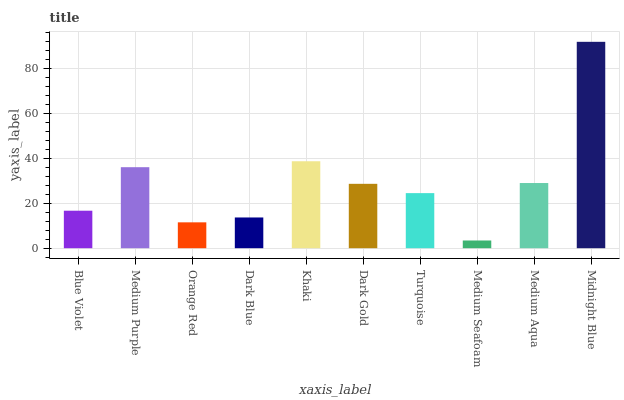Is Medium Seafoam the minimum?
Answer yes or no. Yes. Is Midnight Blue the maximum?
Answer yes or no. Yes. Is Medium Purple the minimum?
Answer yes or no. No. Is Medium Purple the maximum?
Answer yes or no. No. Is Medium Purple greater than Blue Violet?
Answer yes or no. Yes. Is Blue Violet less than Medium Purple?
Answer yes or no. Yes. Is Blue Violet greater than Medium Purple?
Answer yes or no. No. Is Medium Purple less than Blue Violet?
Answer yes or no. No. Is Dark Gold the high median?
Answer yes or no. Yes. Is Turquoise the low median?
Answer yes or no. Yes. Is Khaki the high median?
Answer yes or no. No. Is Dark Gold the low median?
Answer yes or no. No. 